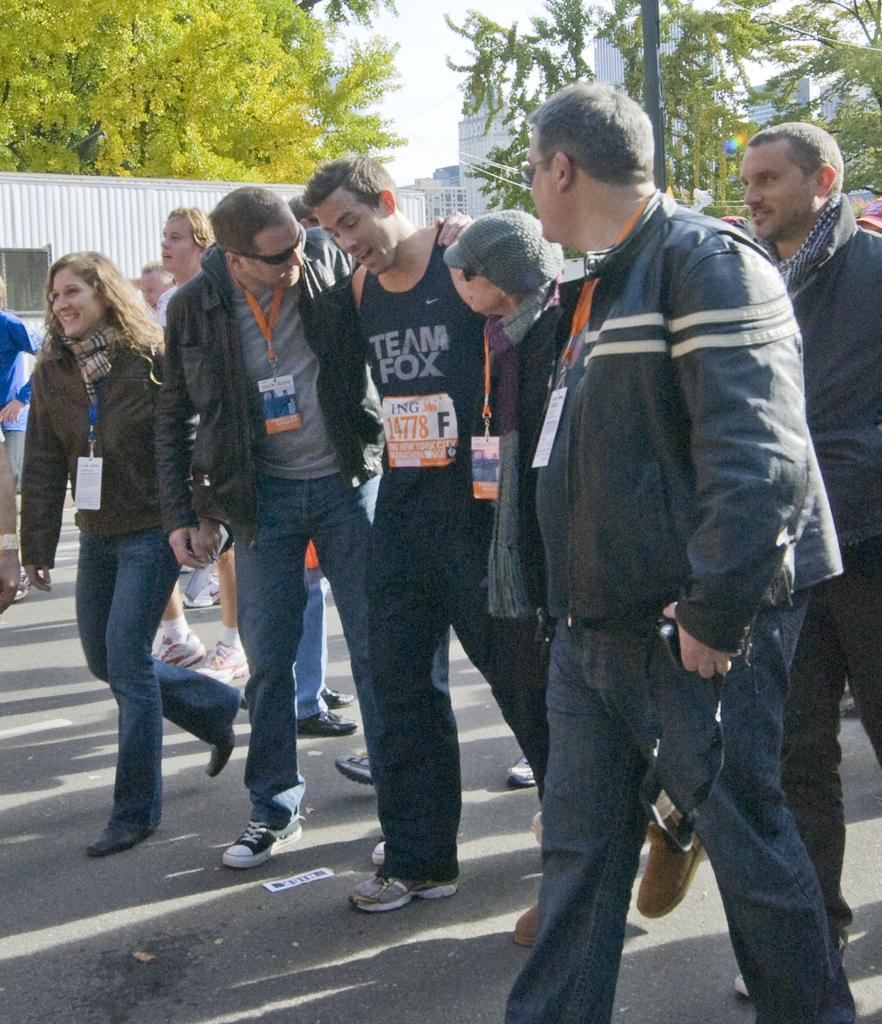What are the people in the image doing? The people in the image are walking on the road. What can be seen in the background of the image? In the background of the image, there are poles, buildings, trees, and the sky. Can you describe the setting of the image? The image shows people walking on a road with various structures and natural elements in the background. What type of magic is being performed in the alley in the image? There is no alley or magic present in the image; it shows people walking on a road with a background of poles, buildings, trees, and the sky. 